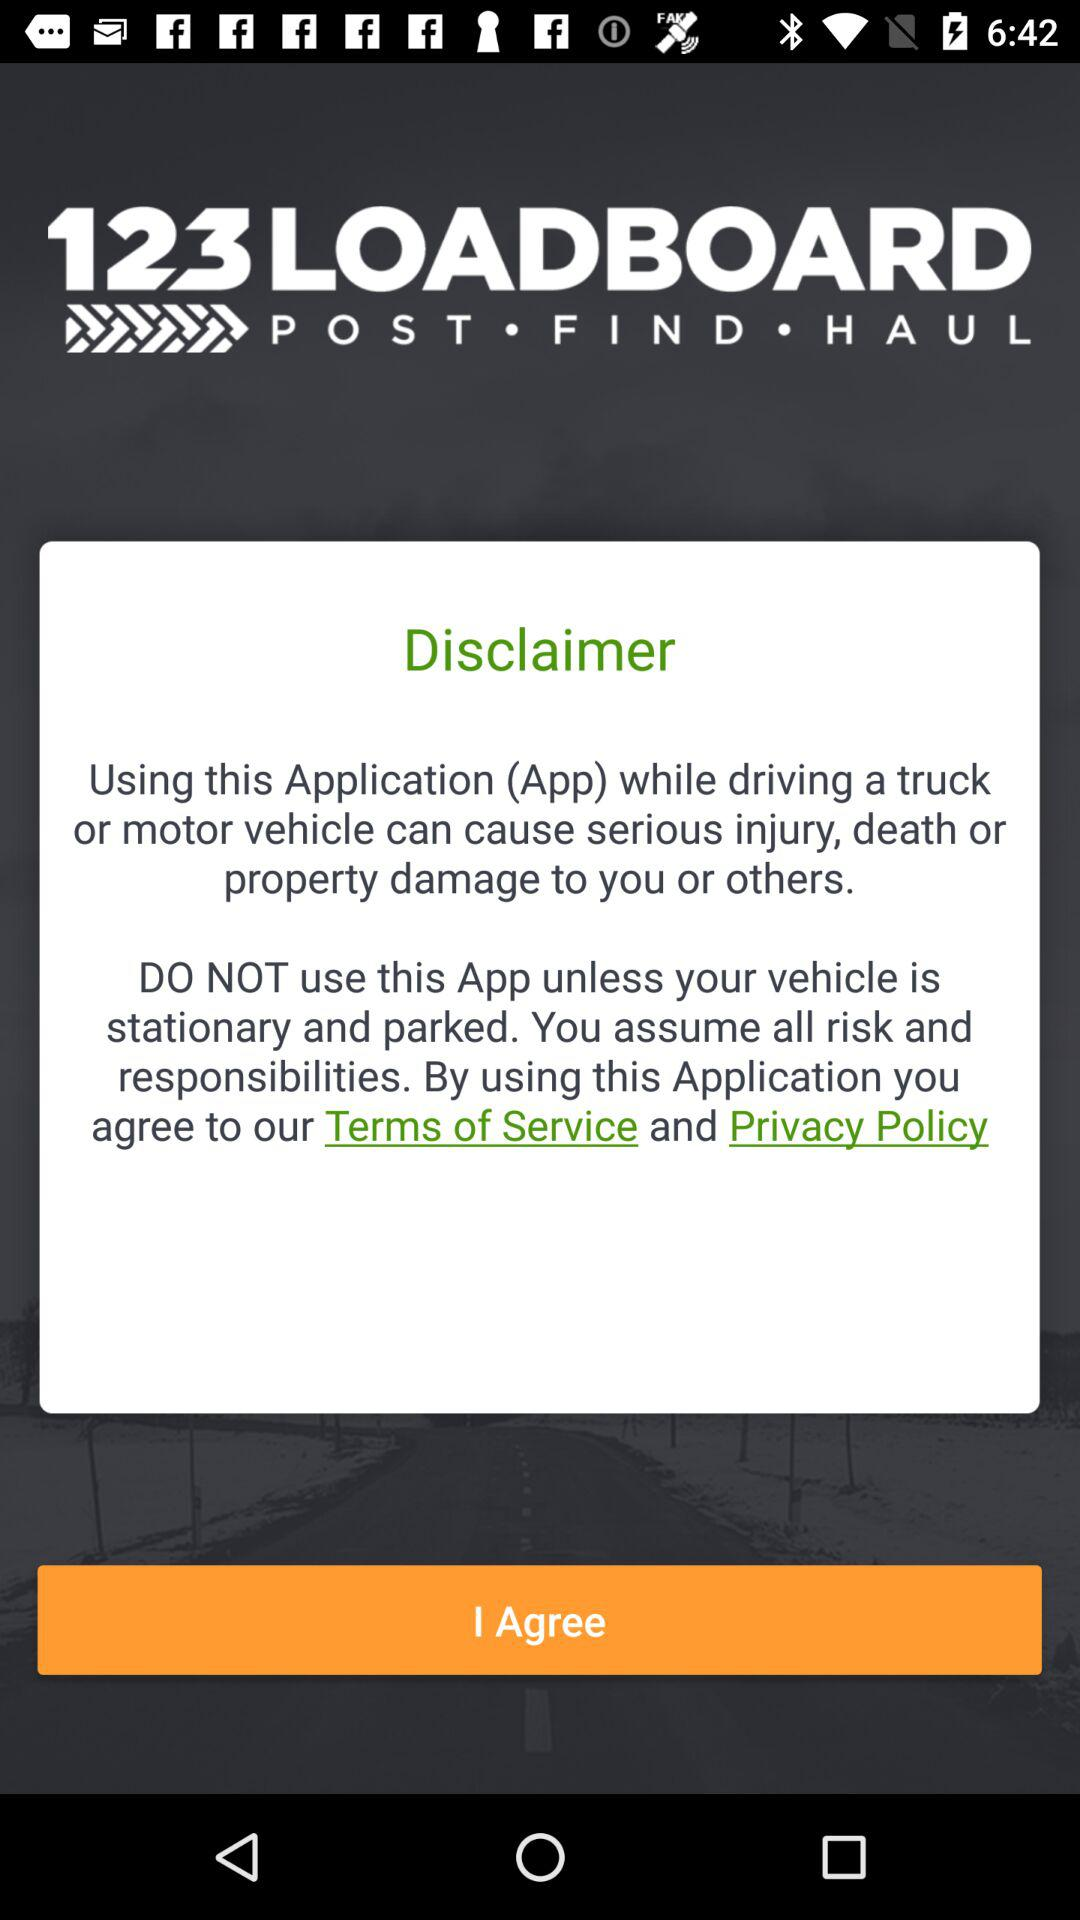What is the app name? The app name is "123LOADBOARD". 